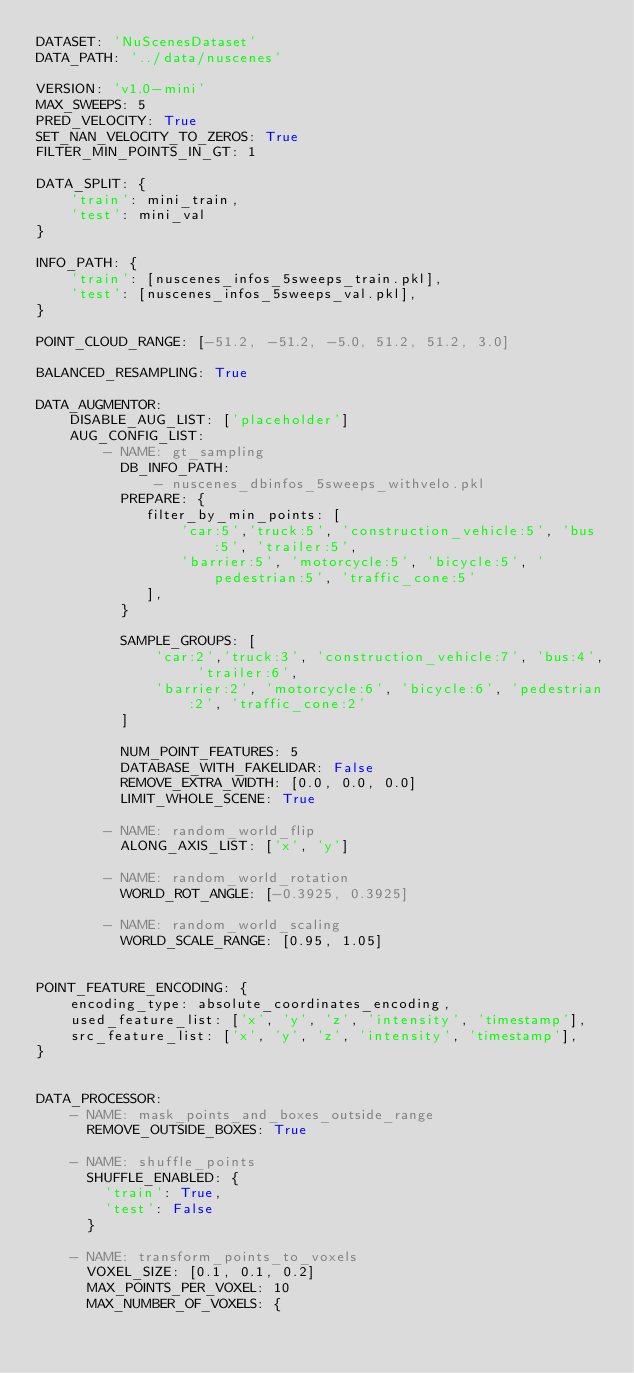Convert code to text. <code><loc_0><loc_0><loc_500><loc_500><_YAML_>DATASET: 'NuScenesDataset'
DATA_PATH: '../data/nuscenes'

VERSION: 'v1.0-mini'
MAX_SWEEPS: 5
PRED_VELOCITY: True
SET_NAN_VELOCITY_TO_ZEROS: True
FILTER_MIN_POINTS_IN_GT: 1

DATA_SPLIT: {
    'train': mini_train,
    'test': mini_val
}

INFO_PATH: {
    'train': [nuscenes_infos_5sweeps_train.pkl],
    'test': [nuscenes_infos_5sweeps_val.pkl],
}

POINT_CLOUD_RANGE: [-51.2, -51.2, -5.0, 51.2, 51.2, 3.0]

BALANCED_RESAMPLING: True 

DATA_AUGMENTOR:
    DISABLE_AUG_LIST: ['placeholder']
    AUG_CONFIG_LIST:
        - NAME: gt_sampling
          DB_INFO_PATH:
              - nuscenes_dbinfos_5sweeps_withvelo.pkl
          PREPARE: {
             filter_by_min_points: [
                 'car:5','truck:5', 'construction_vehicle:5', 'bus:5', 'trailer:5',
                 'barrier:5', 'motorcycle:5', 'bicycle:5', 'pedestrian:5', 'traffic_cone:5'
             ],
          }

          SAMPLE_GROUPS: [
              'car:2','truck:3', 'construction_vehicle:7', 'bus:4', 'trailer:6',
              'barrier:2', 'motorcycle:6', 'bicycle:6', 'pedestrian:2', 'traffic_cone:2'
          ]

          NUM_POINT_FEATURES: 5
          DATABASE_WITH_FAKELIDAR: False
          REMOVE_EXTRA_WIDTH: [0.0, 0.0, 0.0]
          LIMIT_WHOLE_SCENE: True

        - NAME: random_world_flip
          ALONG_AXIS_LIST: ['x', 'y']

        - NAME: random_world_rotation
          WORLD_ROT_ANGLE: [-0.3925, 0.3925]

        - NAME: random_world_scaling
          WORLD_SCALE_RANGE: [0.95, 1.05]


POINT_FEATURE_ENCODING: {
    encoding_type: absolute_coordinates_encoding,
    used_feature_list: ['x', 'y', 'z', 'intensity', 'timestamp'],
    src_feature_list: ['x', 'y', 'z', 'intensity', 'timestamp'],
}


DATA_PROCESSOR:
    - NAME: mask_points_and_boxes_outside_range
      REMOVE_OUTSIDE_BOXES: True

    - NAME: shuffle_points
      SHUFFLE_ENABLED: {
        'train': True,
        'test': False
      }

    - NAME: transform_points_to_voxels
      VOXEL_SIZE: [0.1, 0.1, 0.2]
      MAX_POINTS_PER_VOXEL: 10
      MAX_NUMBER_OF_VOXELS: {</code> 